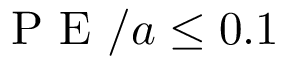<formula> <loc_0><loc_0><loc_500><loc_500>P E / a \leq 0 . 1</formula> 